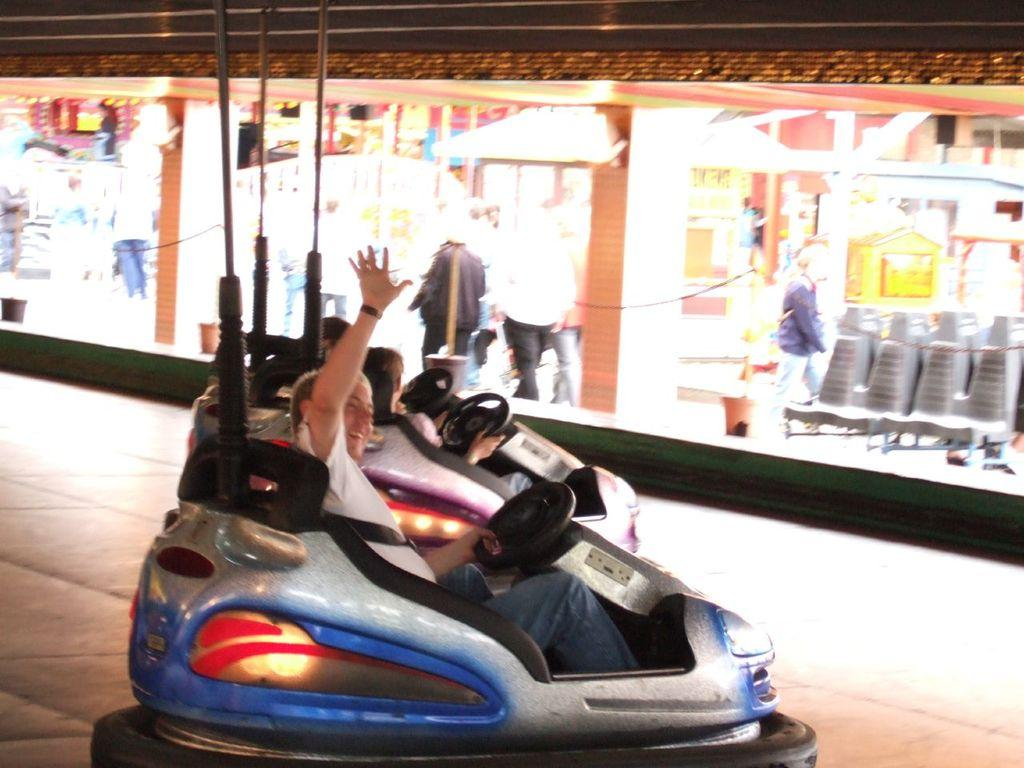What are the people in the image doing? There are people sitting in a vehicle and people walking in the image. What can be seen on the right side of the image? There are chairs on the right side of the image. What is visible in the background of the image? There are buildings in the background of the image. Can you find the fifth person in the image? There is no mention of a fifth person in the image, as there are only people sitting in a vehicle and people walking mentioned. 